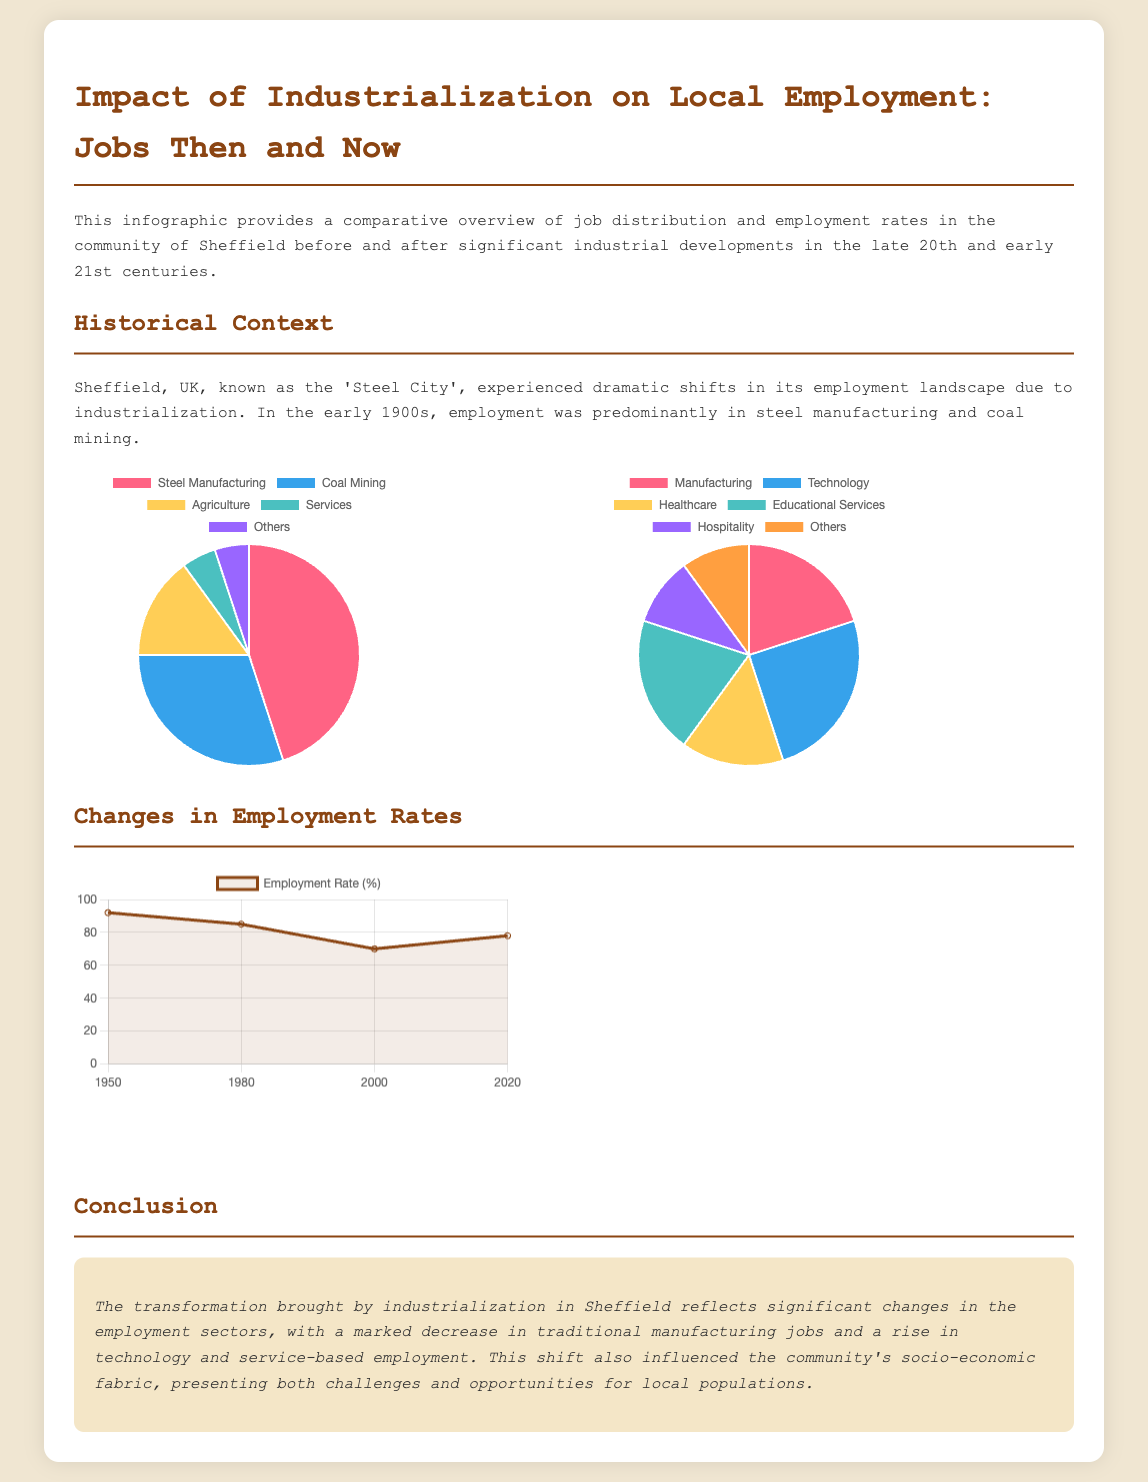What percentage of jobs in 1900 were in steel manufacturing? The pie chart for jobs then shows that 45% of jobs were in steel manufacturing.
Answer: 45% What was the employment rate in 1980? The employment rates chart indicates that the employment rate in 1980 was 85%.
Answer: 85% Which job sector saw the highest percentage of employment now? In the pie chart for jobs now, technology had the highest percentage at 25%.
Answer: Technology What economic shift is highlighted in the conclusion? The conclusion mentions a shift to technology and service-based employment as a significant change.
Answer: Technology and service-based employment What year marked the lowest employment rate according to the chart? The employment rates chart shows that the year 2000 marked the lowest employment rate at 70%.
Answer: 2000 